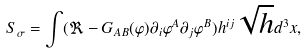<formula> <loc_0><loc_0><loc_500><loc_500>S _ { \sigma } = \int ( \Re - G _ { A B } ( \varphi ) \partial _ { i } \varphi ^ { A } \partial _ { j } \varphi ^ { B } ) h ^ { i j } \sqrt { h } d ^ { 3 } x ,</formula> 